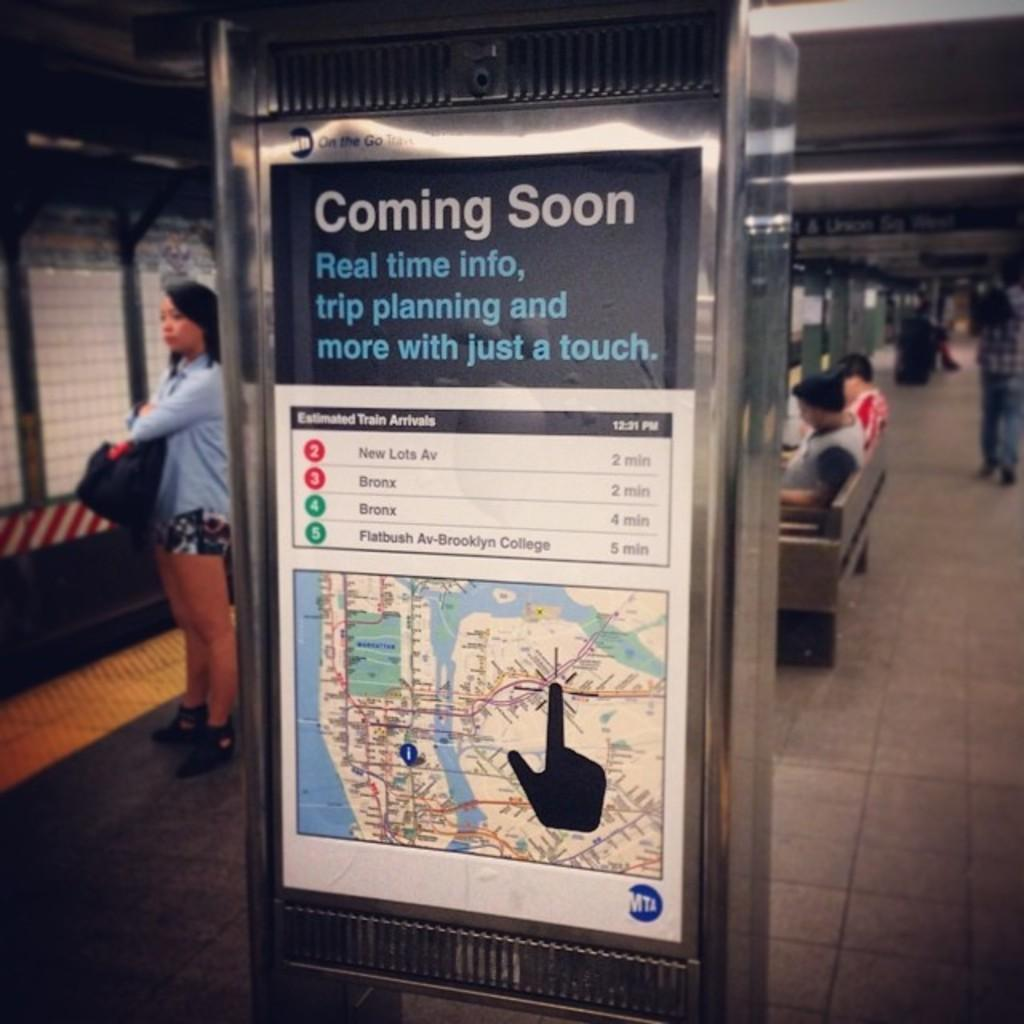<image>
Share a concise interpretation of the image provided. A large sign in a station that says Coming soon ,real time info and a map and more details . 